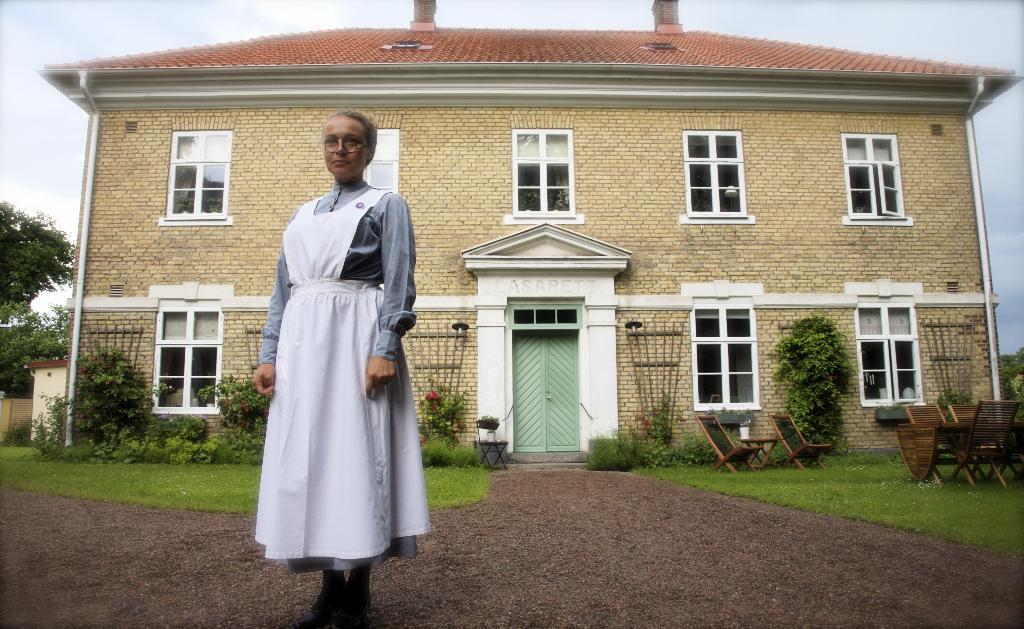Who is the main subject in the image? There is a woman in the image. What is the woman doing in the image? The woman is standing. What is the woman wearing in the image? The woman is wearing a white dress. What can be seen behind the woman in the image? There is a house behind the woman. What furniture is visible on the right side of the image? There are chairs on the right side of the image. What is visible at the top of the image? The sky is visible at the top of the image. Can you tell me how many people are talking in the image? There is no indication of people talking in the image; the woman is standing and not engaged in conversation. What type of seat is the woman using in the image? The woman is standing, so she is not using a seat in the image. 